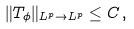<formula> <loc_0><loc_0><loc_500><loc_500>\| T _ { \phi } \| _ { L ^ { p } \to L ^ { p } } \leq C \, ,</formula> 